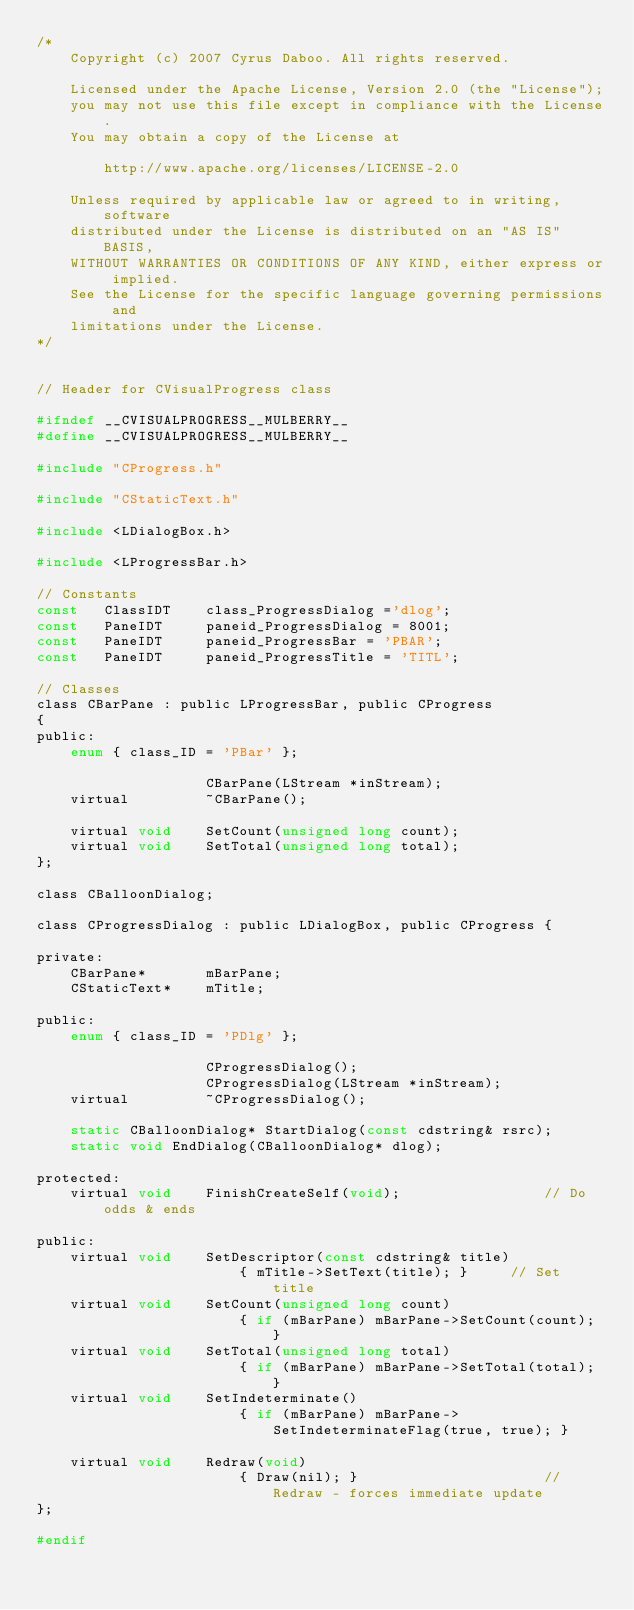<code> <loc_0><loc_0><loc_500><loc_500><_C_>/*
    Copyright (c) 2007 Cyrus Daboo. All rights reserved.
    
    Licensed under the Apache License, Version 2.0 (the "License");
    you may not use this file except in compliance with the License.
    You may obtain a copy of the License at
    
        http://www.apache.org/licenses/LICENSE-2.0
    
    Unless required by applicable law or agreed to in writing, software
    distributed under the License is distributed on an "AS IS" BASIS,
    WITHOUT WARRANTIES OR CONDITIONS OF ANY KIND, either express or implied.
    See the License for the specific language governing permissions and
    limitations under the License.
*/


// Header for CVisualProgress class

#ifndef __CVISUALPROGRESS__MULBERRY__
#define __CVISUALPROGRESS__MULBERRY__

#include "CProgress.h"

#include "CStaticText.h"

#include <LDialogBox.h>

#include <LProgressBar.h>

// Constants
const	ClassIDT	class_ProgressDialog ='dlog';
const	PaneIDT		paneid_ProgressDialog = 8001;
const	PaneIDT		paneid_ProgressBar = 'PBAR';
const	PaneIDT		paneid_ProgressTitle = 'TITL';

// Classes
class CBarPane : public LProgressBar, public CProgress
{
public:
	enum { class_ID = 'PBar' };

					CBarPane(LStream *inStream);
	virtual			~CBarPane();
	
	virtual void	SetCount(unsigned long count);
	virtual void	SetTotal(unsigned long total);
};

class CBalloonDialog;

class CProgressDialog : public LDialogBox, public CProgress {

private:
	CBarPane*		mBarPane;
	CStaticText*	mTitle;

public:
	enum { class_ID = 'PDlg' };

					CProgressDialog();
					CProgressDialog(LStream *inStream);
	virtual			~CProgressDialog();

	static CBalloonDialog* StartDialog(const cdstring& rsrc);
	static void EndDialog(CBalloonDialog* dlog);

protected:
	virtual void	FinishCreateSelf(void);					// Do odds & ends

public:
	virtual void	SetDescriptor(const cdstring& title)
						{ mTitle->SetText(title); }		// Set title
	virtual void	SetCount(unsigned long count) 
						{ if (mBarPane) mBarPane->SetCount(count); }
	virtual void	SetTotal(unsigned long total) 
						{ if (mBarPane) mBarPane->SetTotal(total); }
	virtual void	SetIndeterminate()
						{ if (mBarPane) mBarPane->SetIndeterminateFlag(true, true); }
	
	virtual void	Redraw(void)
						{ Draw(nil); }						// Redraw - forces immediate update
};

#endif
</code> 